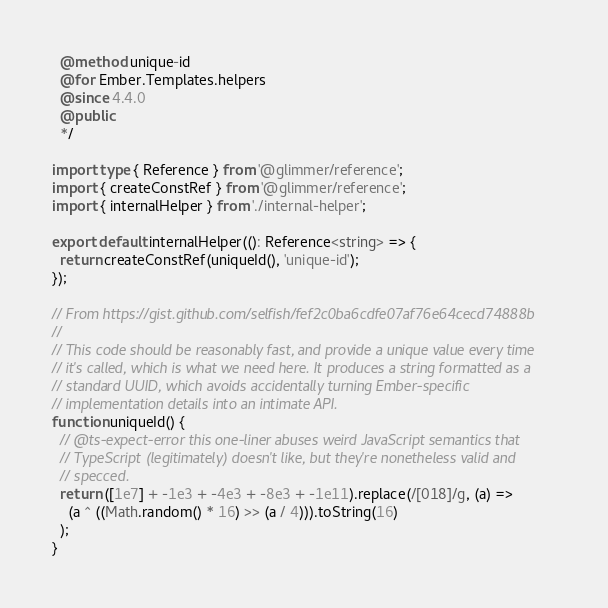<code> <loc_0><loc_0><loc_500><loc_500><_TypeScript_>  @method unique-id
  @for Ember.Templates.helpers
  @since 4.4.0
  @public
  */

import type { Reference } from '@glimmer/reference';
import { createConstRef } from '@glimmer/reference';
import { internalHelper } from './internal-helper';

export default internalHelper((): Reference<string> => {
  return createConstRef(uniqueId(), 'unique-id');
});

// From https://gist.github.com/selfish/fef2c0ba6cdfe07af76e64cecd74888b
//
// This code should be reasonably fast, and provide a unique value every time
// it's called, which is what we need here. It produces a string formatted as a
// standard UUID, which avoids accidentally turning Ember-specific
// implementation details into an intimate API.
function uniqueId() {
  // @ts-expect-error this one-liner abuses weird JavaScript semantics that
  // TypeScript (legitimately) doesn't like, but they're nonetheless valid and
  // specced.
  return ([1e7] + -1e3 + -4e3 + -8e3 + -1e11).replace(/[018]/g, (a) =>
    (a ^ ((Math.random() * 16) >> (a / 4))).toString(16)
  );
}
</code> 